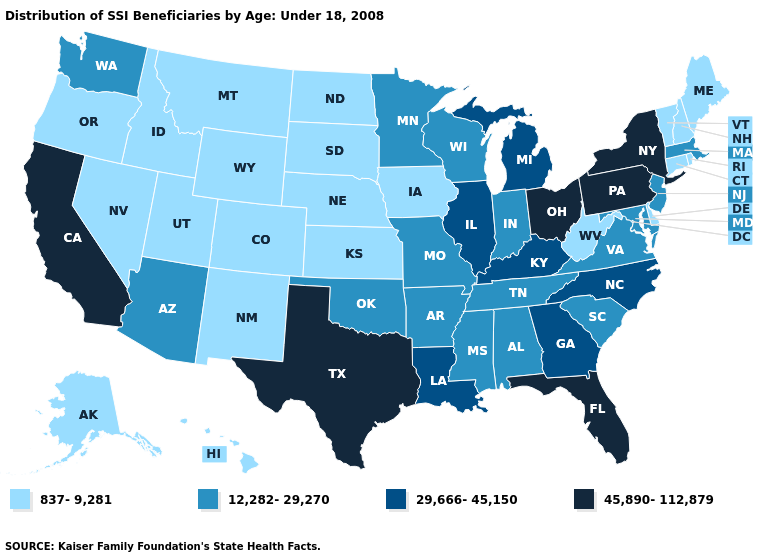Name the states that have a value in the range 12,282-29,270?
Write a very short answer. Alabama, Arizona, Arkansas, Indiana, Maryland, Massachusetts, Minnesota, Mississippi, Missouri, New Jersey, Oklahoma, South Carolina, Tennessee, Virginia, Washington, Wisconsin. What is the value of Alabama?
Answer briefly. 12,282-29,270. What is the value of West Virginia?
Answer briefly. 837-9,281. What is the value of New York?
Short answer required. 45,890-112,879. What is the highest value in the USA?
Give a very brief answer. 45,890-112,879. Which states hav the highest value in the West?
Keep it brief. California. What is the value of Indiana?
Write a very short answer. 12,282-29,270. Does Texas have the highest value in the South?
Keep it brief. Yes. Among the states that border Wyoming , which have the lowest value?
Short answer required. Colorado, Idaho, Montana, Nebraska, South Dakota, Utah. Does the first symbol in the legend represent the smallest category?
Give a very brief answer. Yes. Name the states that have a value in the range 837-9,281?
Quick response, please. Alaska, Colorado, Connecticut, Delaware, Hawaii, Idaho, Iowa, Kansas, Maine, Montana, Nebraska, Nevada, New Hampshire, New Mexico, North Dakota, Oregon, Rhode Island, South Dakota, Utah, Vermont, West Virginia, Wyoming. What is the highest value in states that border Michigan?
Give a very brief answer. 45,890-112,879. Among the states that border Virginia , does Kentucky have the highest value?
Concise answer only. Yes. Among the states that border North Carolina , does Georgia have the lowest value?
Answer briefly. No. Does Texas have the highest value in the South?
Answer briefly. Yes. 